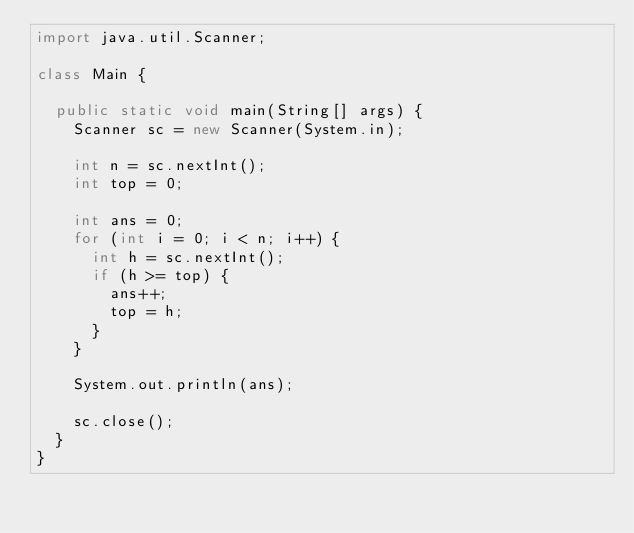Convert code to text. <code><loc_0><loc_0><loc_500><loc_500><_Java_>import java.util.Scanner;

class Main {

	public static void main(String[] args) {
		Scanner sc = new Scanner(System.in);

		int n = sc.nextInt();
		int top = 0;

		int ans = 0;
		for (int i = 0; i < n; i++) {
			int h = sc.nextInt();
			if (h >= top) {
				ans++;
				top = h;
			}
		}

		System.out.println(ans);

		sc.close();
	}
}
</code> 